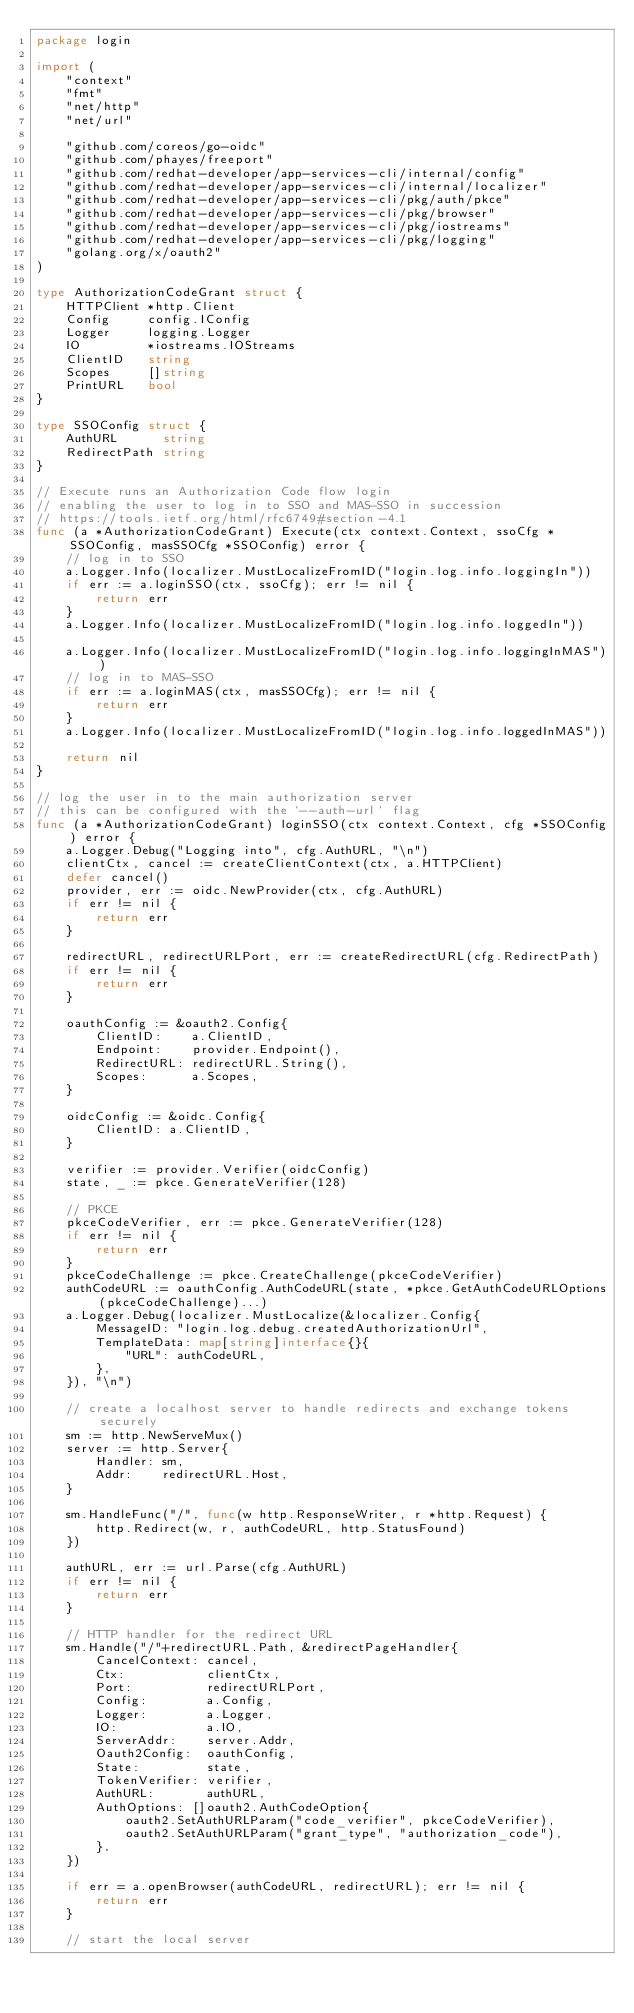Convert code to text. <code><loc_0><loc_0><loc_500><loc_500><_Go_>package login

import (
	"context"
	"fmt"
	"net/http"
	"net/url"

	"github.com/coreos/go-oidc"
	"github.com/phayes/freeport"
	"github.com/redhat-developer/app-services-cli/internal/config"
	"github.com/redhat-developer/app-services-cli/internal/localizer"
	"github.com/redhat-developer/app-services-cli/pkg/auth/pkce"
	"github.com/redhat-developer/app-services-cli/pkg/browser"
	"github.com/redhat-developer/app-services-cli/pkg/iostreams"
	"github.com/redhat-developer/app-services-cli/pkg/logging"
	"golang.org/x/oauth2"
)

type AuthorizationCodeGrant struct {
	HTTPClient *http.Client
	Config     config.IConfig
	Logger     logging.Logger
	IO         *iostreams.IOStreams
	ClientID   string
	Scopes     []string
	PrintURL   bool
}

type SSOConfig struct {
	AuthURL      string
	RedirectPath string
}

// Execute runs an Authorization Code flow login
// enabling the user to log in to SSO and MAS-SSO in succession
// https://tools.ietf.org/html/rfc6749#section-4.1
func (a *AuthorizationCodeGrant) Execute(ctx context.Context, ssoCfg *SSOConfig, masSSOCfg *SSOConfig) error {
	// log in to SSO
	a.Logger.Info(localizer.MustLocalizeFromID("login.log.info.loggingIn"))
	if err := a.loginSSO(ctx, ssoCfg); err != nil {
		return err
	}
	a.Logger.Info(localizer.MustLocalizeFromID("login.log.info.loggedIn"))

	a.Logger.Info(localizer.MustLocalizeFromID("login.log.info.loggingInMAS"))
	// log in to MAS-SSO
	if err := a.loginMAS(ctx, masSSOCfg); err != nil {
		return err
	}
	a.Logger.Info(localizer.MustLocalizeFromID("login.log.info.loggedInMAS"))

	return nil
}

// log the user in to the main authorization server
// this can be configured with the `--auth-url` flag
func (a *AuthorizationCodeGrant) loginSSO(ctx context.Context, cfg *SSOConfig) error {
	a.Logger.Debug("Logging into", cfg.AuthURL, "\n")
	clientCtx, cancel := createClientContext(ctx, a.HTTPClient)
	defer cancel()
	provider, err := oidc.NewProvider(ctx, cfg.AuthURL)
	if err != nil {
		return err
	}

	redirectURL, redirectURLPort, err := createRedirectURL(cfg.RedirectPath)
	if err != nil {
		return err
	}

	oauthConfig := &oauth2.Config{
		ClientID:    a.ClientID,
		Endpoint:    provider.Endpoint(),
		RedirectURL: redirectURL.String(),
		Scopes:      a.Scopes,
	}

	oidcConfig := &oidc.Config{
		ClientID: a.ClientID,
	}

	verifier := provider.Verifier(oidcConfig)
	state, _ := pkce.GenerateVerifier(128)

	// PKCE
	pkceCodeVerifier, err := pkce.GenerateVerifier(128)
	if err != nil {
		return err
	}
	pkceCodeChallenge := pkce.CreateChallenge(pkceCodeVerifier)
	authCodeURL := oauthConfig.AuthCodeURL(state, *pkce.GetAuthCodeURLOptions(pkceCodeChallenge)...)
	a.Logger.Debug(localizer.MustLocalize(&localizer.Config{
		MessageID: "login.log.debug.createdAuthorizationUrl",
		TemplateData: map[string]interface{}{
			"URL": authCodeURL,
		},
	}), "\n")

	// create a localhost server to handle redirects and exchange tokens securely
	sm := http.NewServeMux()
	server := http.Server{
		Handler: sm,
		Addr:    redirectURL.Host,
	}

	sm.HandleFunc("/", func(w http.ResponseWriter, r *http.Request) {
		http.Redirect(w, r, authCodeURL, http.StatusFound)
	})

	authURL, err := url.Parse(cfg.AuthURL)
	if err != nil {
		return err
	}

	// HTTP handler for the redirect URL
	sm.Handle("/"+redirectURL.Path, &redirectPageHandler{
		CancelContext: cancel,
		Ctx:           clientCtx,
		Port:          redirectURLPort,
		Config:        a.Config,
		Logger:        a.Logger,
		IO:            a.IO,
		ServerAddr:    server.Addr,
		Oauth2Config:  oauthConfig,
		State:         state,
		TokenVerifier: verifier,
		AuthURL:       authURL,
		AuthOptions: []oauth2.AuthCodeOption{
			oauth2.SetAuthURLParam("code_verifier", pkceCodeVerifier),
			oauth2.SetAuthURLParam("grant_type", "authorization_code"),
		},
	})

	if err = a.openBrowser(authCodeURL, redirectURL); err != nil {
		return err
	}

	// start the local server</code> 